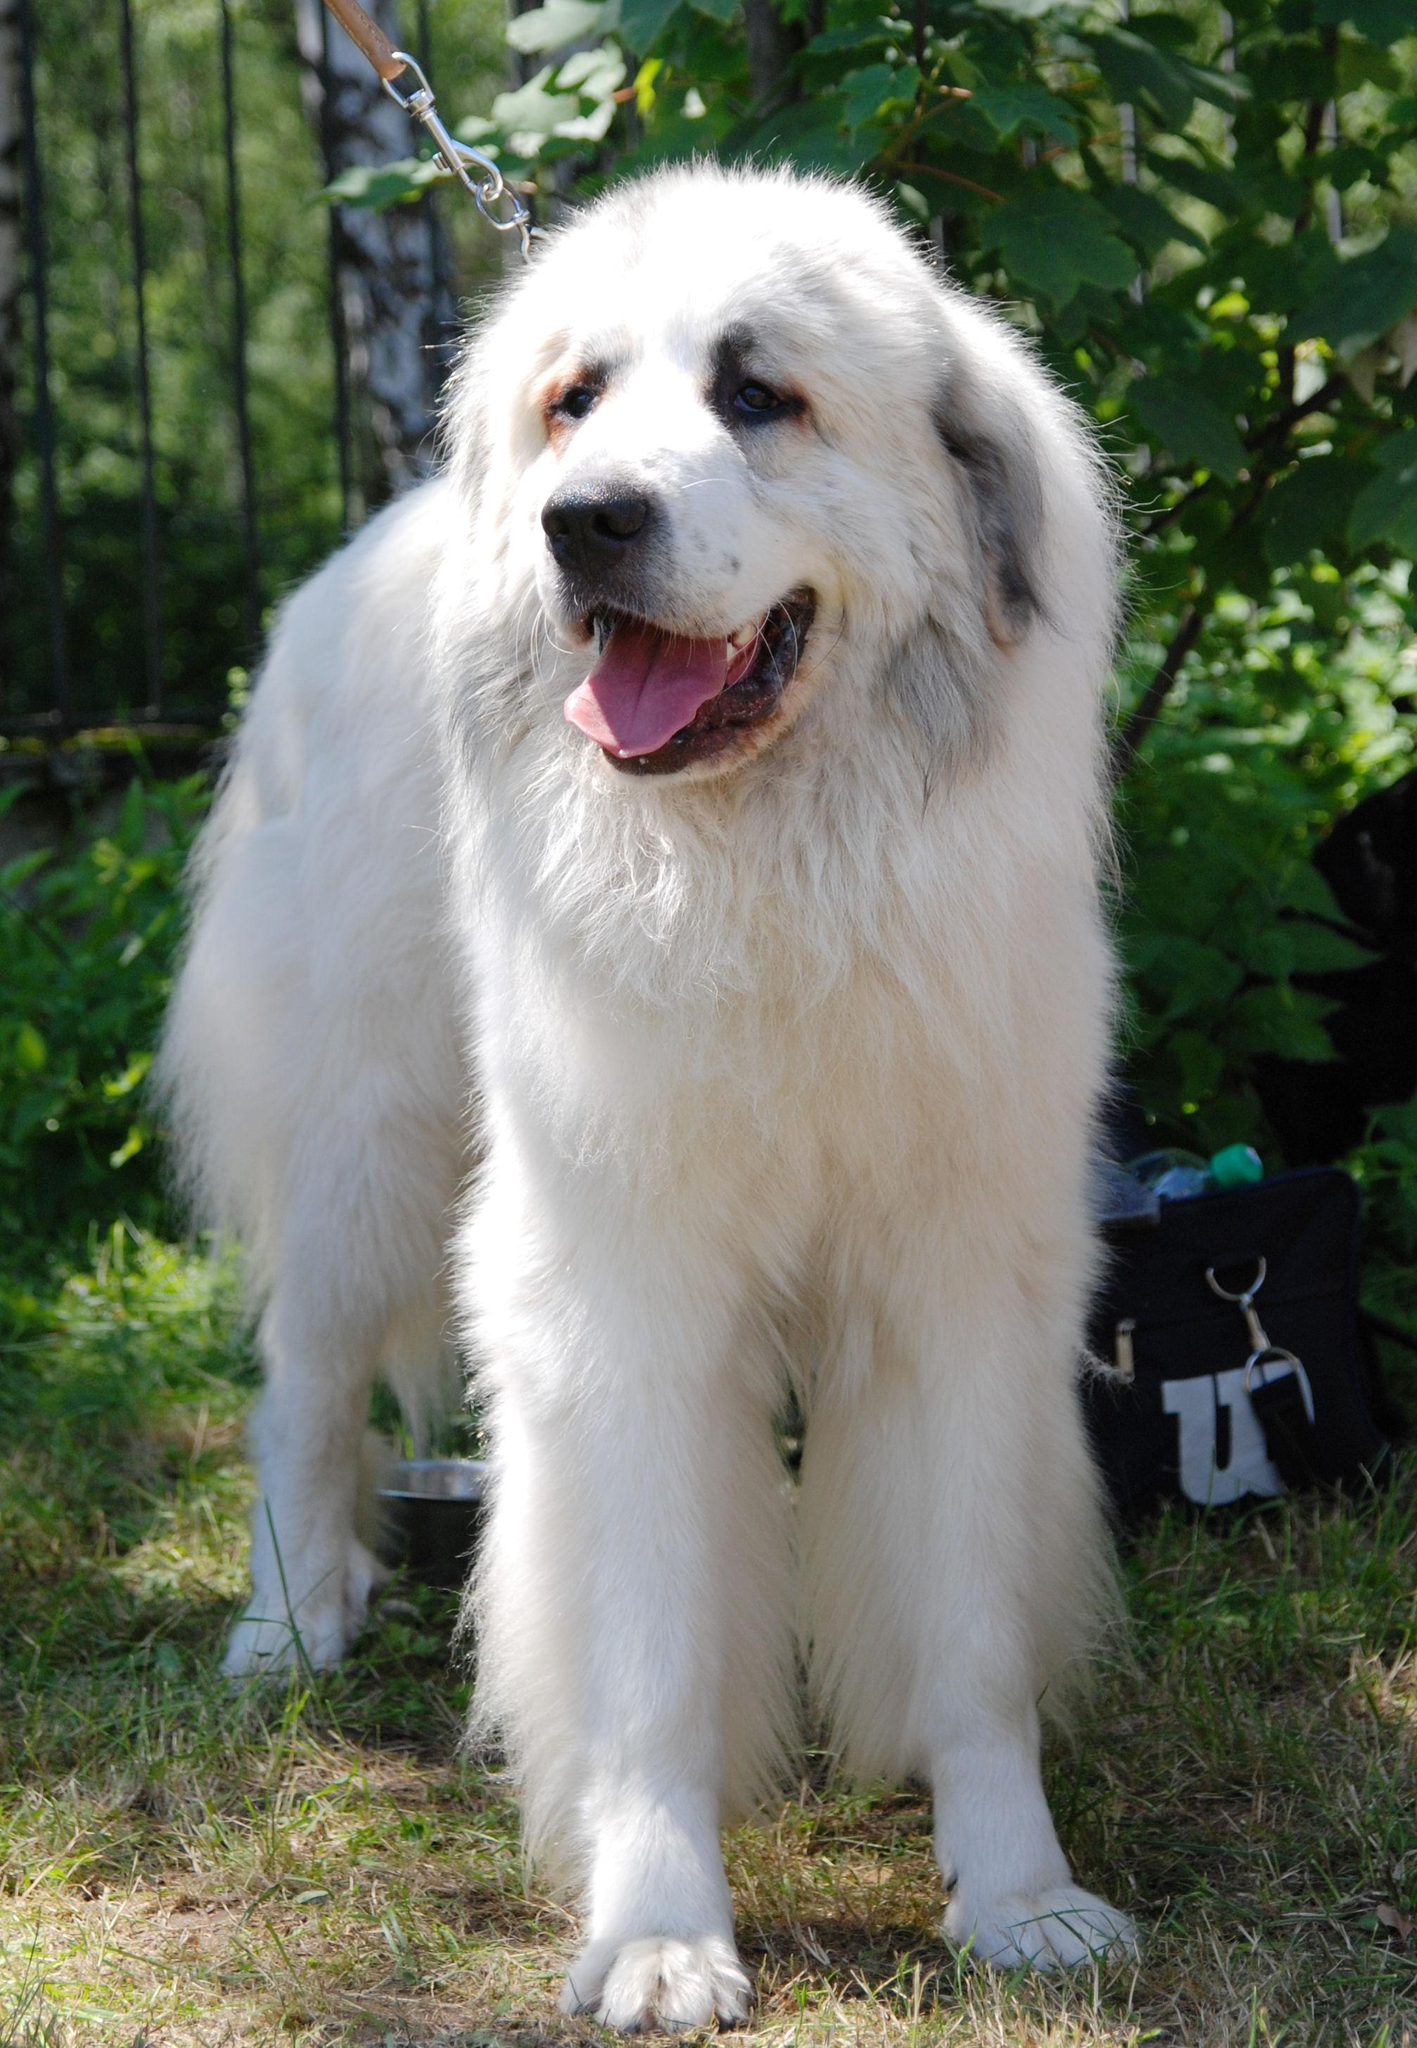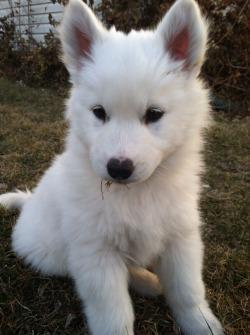The first image is the image on the left, the second image is the image on the right. Considering the images on both sides, is "One image shows a puppy on the grass." valid? Answer yes or no. Yes. 